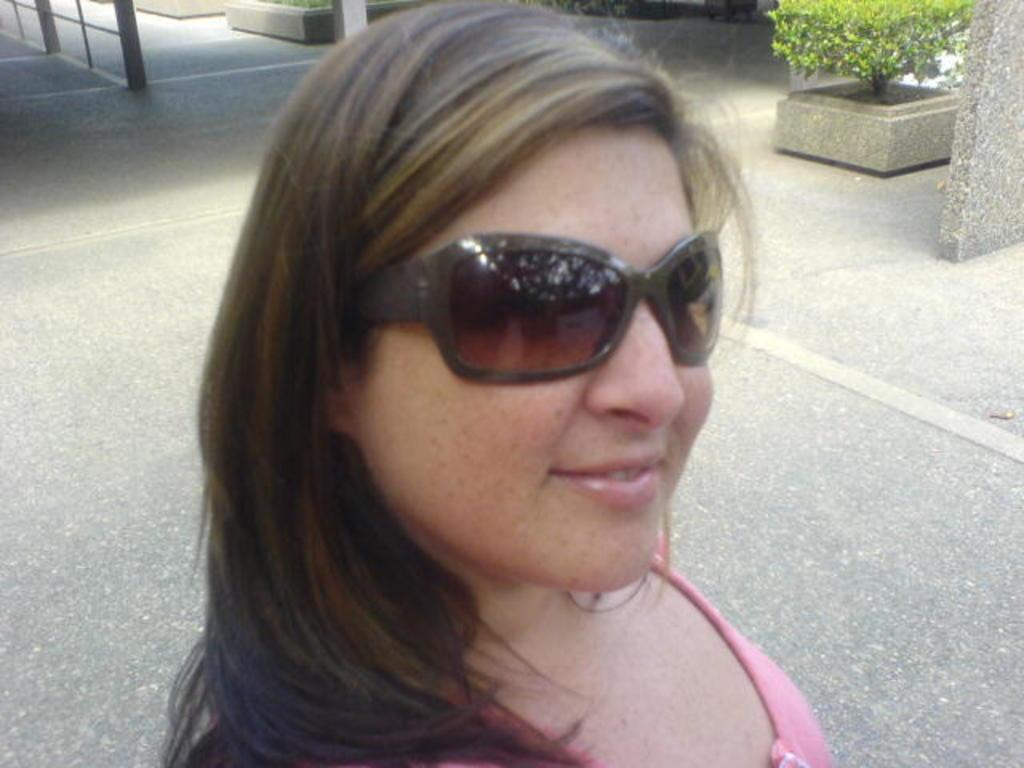Who is the main subject in the image? There is a woman in the image. Where is the woman positioned in the image? The woman is standing at the front. What can be seen in the background of the image? There are flower pots in the background of the image. What type of cast is visible on the woman's arm in the image? There is no cast visible on the woman's arm in the image. What store can be seen in the background of the image? There is no store present in the image; it only features a woman standing at the front and flower pots in the background. 